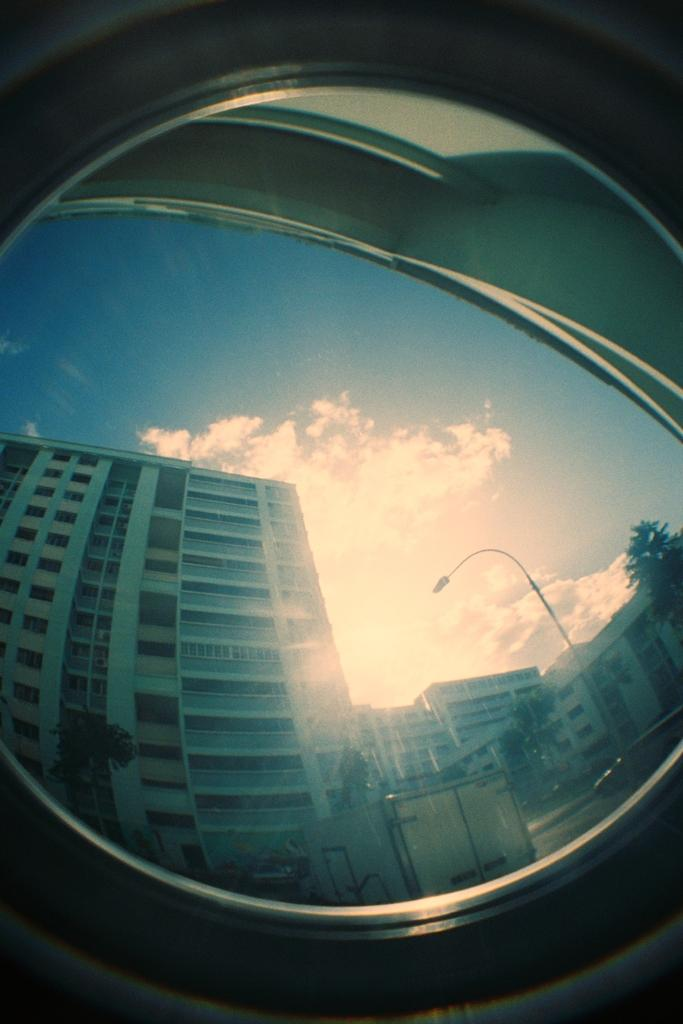What type of image is being displayed? The image is a 360-degree picture. What object can be seen in the image? There is a mirror in the image. What can be seen in the mirror? The sky is visible in the mirror. What else is being reflected in the mirror? Many buildings are being reflected in the mirror. How many kittens are sitting on the support in the image? There are no kittens or supports present in the image. What type of key is being used to unlock the door in the image? There is no door or key present in the image. 